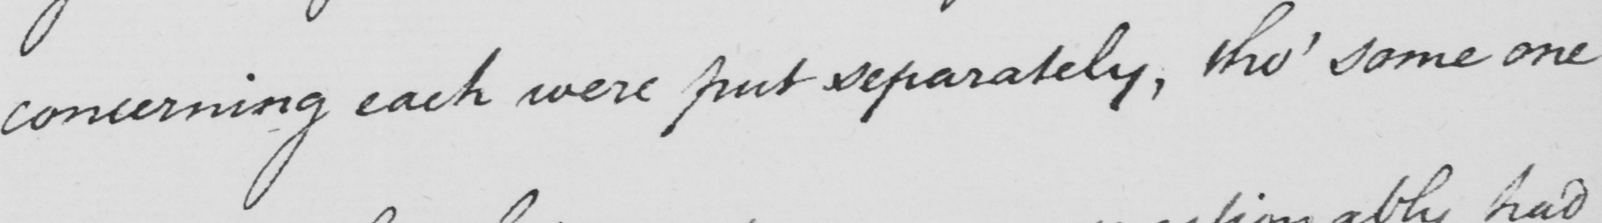Transcribe the text shown in this historical manuscript line. concerning each were put separately, tho' some one 